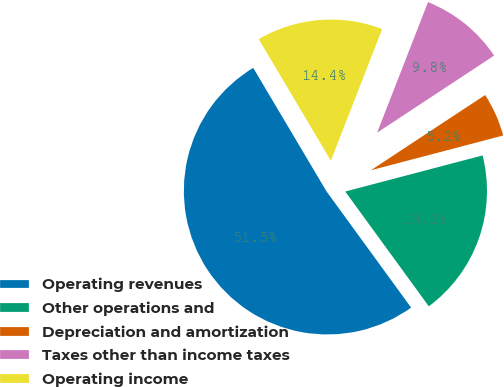Convert chart. <chart><loc_0><loc_0><loc_500><loc_500><pie_chart><fcel>Operating revenues<fcel>Other operations and<fcel>Depreciation and amortization<fcel>Taxes other than income taxes<fcel>Operating income<nl><fcel>51.48%<fcel>19.07%<fcel>5.18%<fcel>9.81%<fcel>14.44%<nl></chart> 